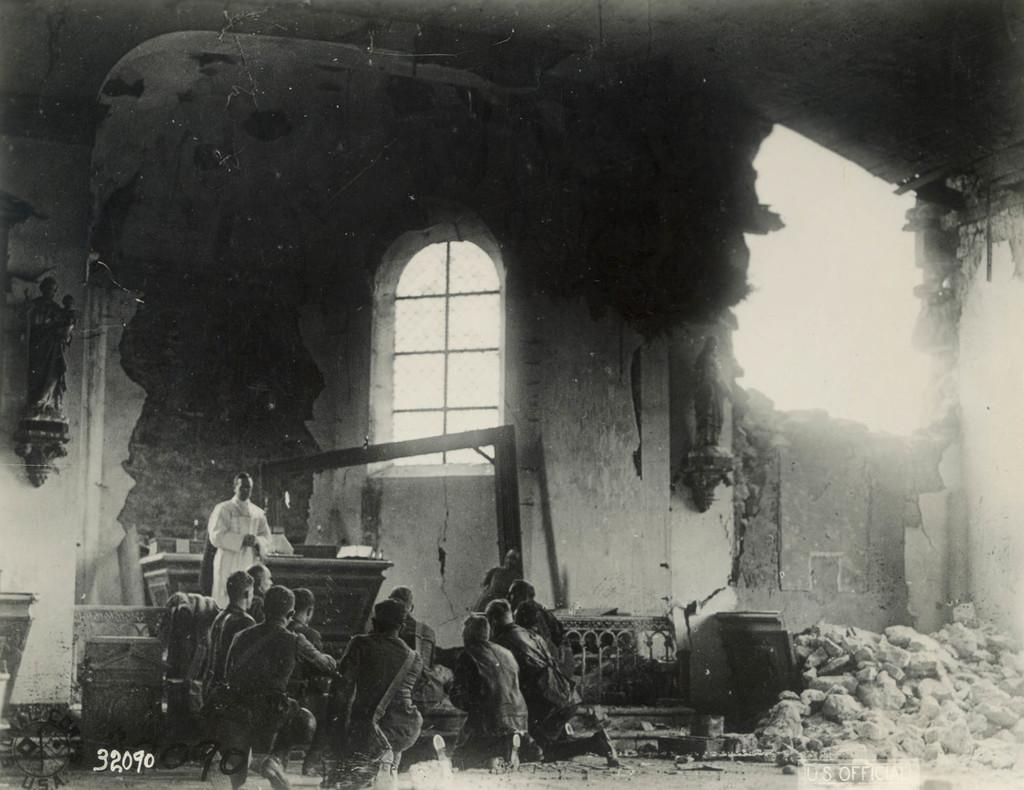How many people are in the image? There is a group of people in the image. What can be seen in the background of the image? There is a wall visible in the background of the image. What is present on the ground in the image? There are stones in the image. Is there any opening or passage in the image? Yes, there is a window in the image. What type of market can be seen in the image? There is no market present in the image. What is the carpenter working on in the image? There is no carpenter or any work being done in the image. 